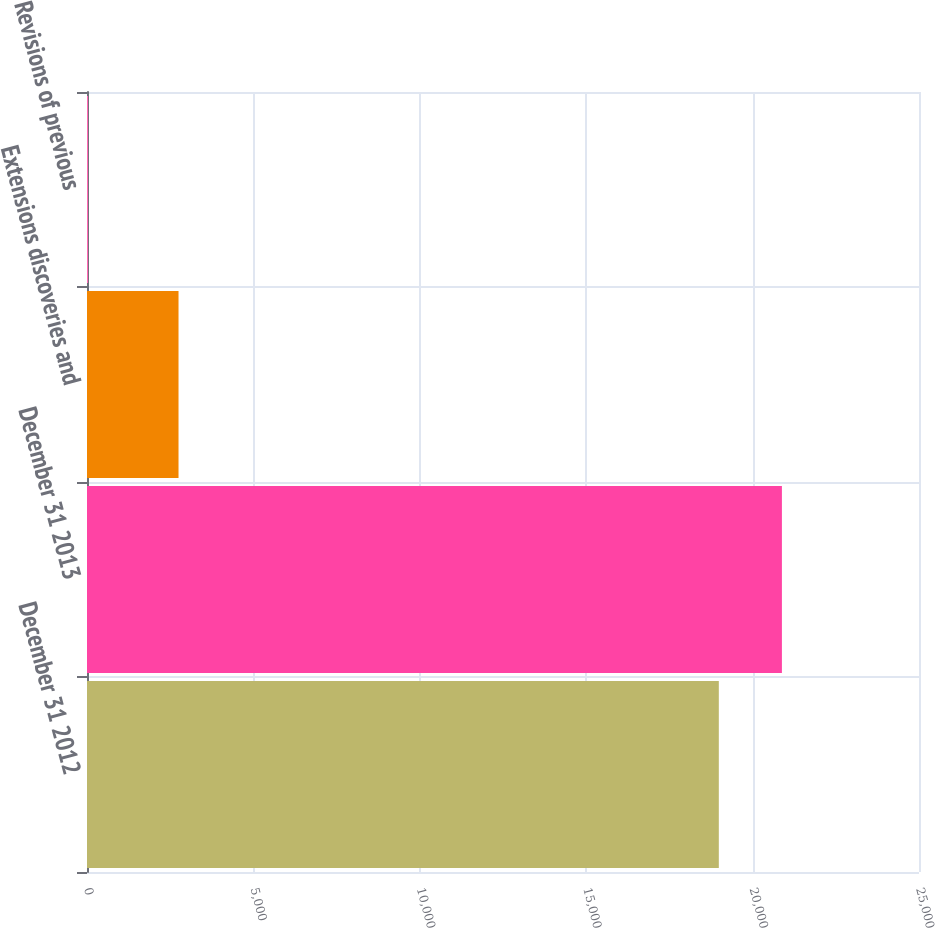<chart> <loc_0><loc_0><loc_500><loc_500><bar_chart><fcel>December 31 2012<fcel>December 31 2013<fcel>Extensions discoveries and<fcel>Revisions of previous<nl><fcel>18985<fcel>20880.6<fcel>2750<fcel>32<nl></chart> 